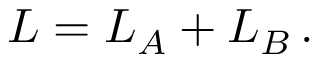Convert formula to latex. <formula><loc_0><loc_0><loc_500><loc_500>L = L _ { A } + L _ { B } \, .</formula> 